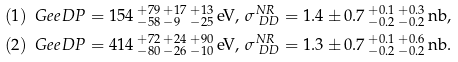<formula> <loc_0><loc_0><loc_500><loc_500>& ( 1 ) \, \ G e e D P = 1 5 4 \, ^ { + 7 9 } _ { - 5 8 } \, ^ { + 1 7 } _ { - 9 } \, ^ { + 1 3 } _ { - 2 5 } \, \text {eV} , \, \sigma ^ { N R } _ { \ D D } = 1 . 4 \pm 0 . 7 \, ^ { + 0 . 1 } _ { - 0 . 2 } \, ^ { + 0 . 3 } _ { - 0 . 2 } \, \text {nb} , \\ & ( 2 ) \, \ G e e D P = 4 1 4 \, ^ { + 7 2 } _ { - 8 0 } \, ^ { + 2 4 } _ { - 2 6 } \, ^ { + 9 0 } _ { - 1 0 } \, \text {eV} , \, \sigma ^ { N R } _ { \ D D } = 1 . 3 \pm 0 . 7 \, ^ { + 0 . 1 } _ { - 0 . 2 } \, ^ { + 0 . 6 } _ { - 0 . 2 } \, \text {nb} . \\</formula> 